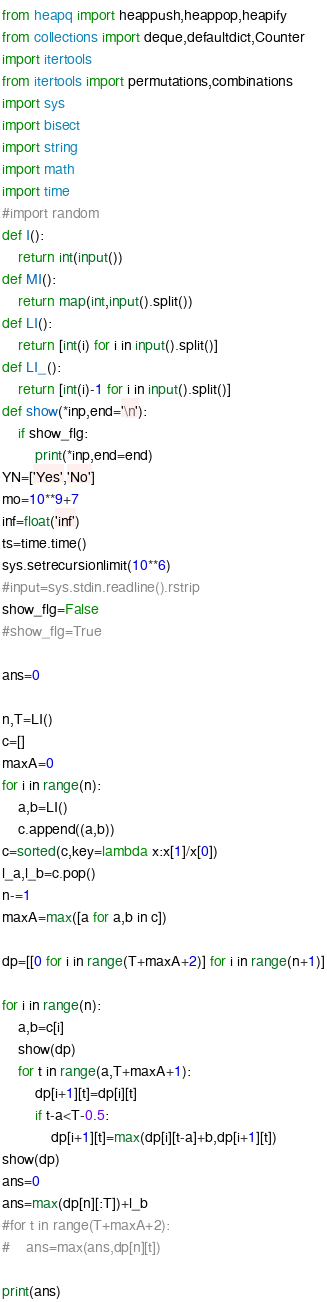<code> <loc_0><loc_0><loc_500><loc_500><_Python_>from heapq import heappush,heappop,heapify
from collections import deque,defaultdict,Counter
import itertools
from itertools import permutations,combinations
import sys
import bisect
import string
import math
import time
#import random
def I():
    return int(input())
def MI():
    return map(int,input().split())
def LI():
    return [int(i) for i in input().split()]
def LI_():
    return [int(i)-1 for i in input().split()]
def show(*inp,end='\n'):
    if show_flg:
        print(*inp,end=end)
YN=['Yes','No']
mo=10**9+7
inf=float('inf')
ts=time.time()
sys.setrecursionlimit(10**6)
#input=sys.stdin.readline().rstrip
show_flg=False
#show_flg=True

ans=0

n,T=LI()
c=[]
maxA=0
for i in range(n):
    a,b=LI()
    c.append((a,b))
c=sorted(c,key=lambda x:x[1]/x[0])
l_a,l_b=c.pop()
n-=1
maxA=max([a for a,b in c])

dp=[[0 for i in range(T+maxA+2)] for i in range(n+1)]

for i in range(n):
    a,b=c[i]
    show(dp)
    for t in range(a,T+maxA+1):
        dp[i+1][t]=dp[i][t]
        if t-a<T-0.5:
            dp[i+1][t]=max(dp[i][t-a]+b,dp[i+1][t])
show(dp)
ans=0
ans=max(dp[n][:T])+l_b
#for t in range(T+maxA+2):
#    ans=max(ans,dp[n][t])
        
print(ans)</code> 